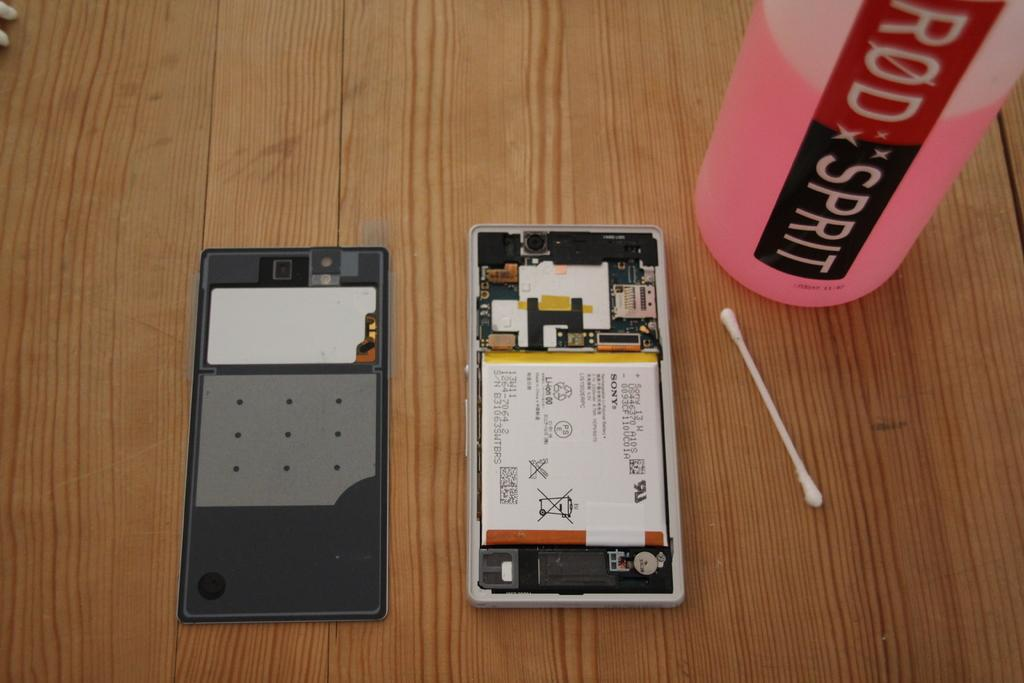Provide a one-sentence caption for the provided image. A cotton bud next to a half full bottle which reads Rod Spirit. 